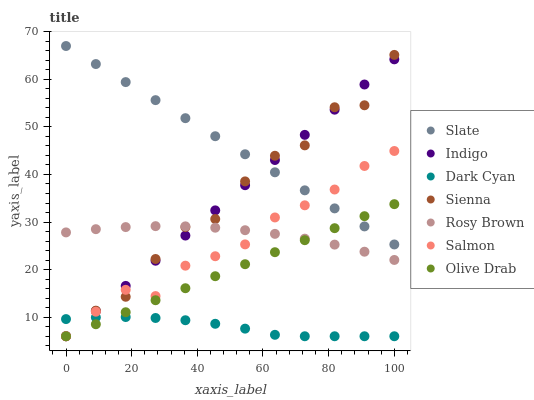Does Dark Cyan have the minimum area under the curve?
Answer yes or no. Yes. Does Slate have the maximum area under the curve?
Answer yes or no. Yes. Does Rosy Brown have the minimum area under the curve?
Answer yes or no. No. Does Rosy Brown have the maximum area under the curve?
Answer yes or no. No. Is Indigo the smoothest?
Answer yes or no. Yes. Is Sienna the roughest?
Answer yes or no. Yes. Is Slate the smoothest?
Answer yes or no. No. Is Slate the roughest?
Answer yes or no. No. Does Indigo have the lowest value?
Answer yes or no. Yes. Does Rosy Brown have the lowest value?
Answer yes or no. No. Does Slate have the highest value?
Answer yes or no. Yes. Does Rosy Brown have the highest value?
Answer yes or no. No. Is Dark Cyan less than Slate?
Answer yes or no. Yes. Is Rosy Brown greater than Dark Cyan?
Answer yes or no. Yes. Does Rosy Brown intersect Olive Drab?
Answer yes or no. Yes. Is Rosy Brown less than Olive Drab?
Answer yes or no. No. Is Rosy Brown greater than Olive Drab?
Answer yes or no. No. Does Dark Cyan intersect Slate?
Answer yes or no. No. 